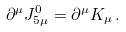Convert formula to latex. <formula><loc_0><loc_0><loc_500><loc_500>\partial ^ { \mu } J _ { 5 \mu } ^ { 0 } = \partial ^ { \mu } K _ { \mu } \, .</formula> 